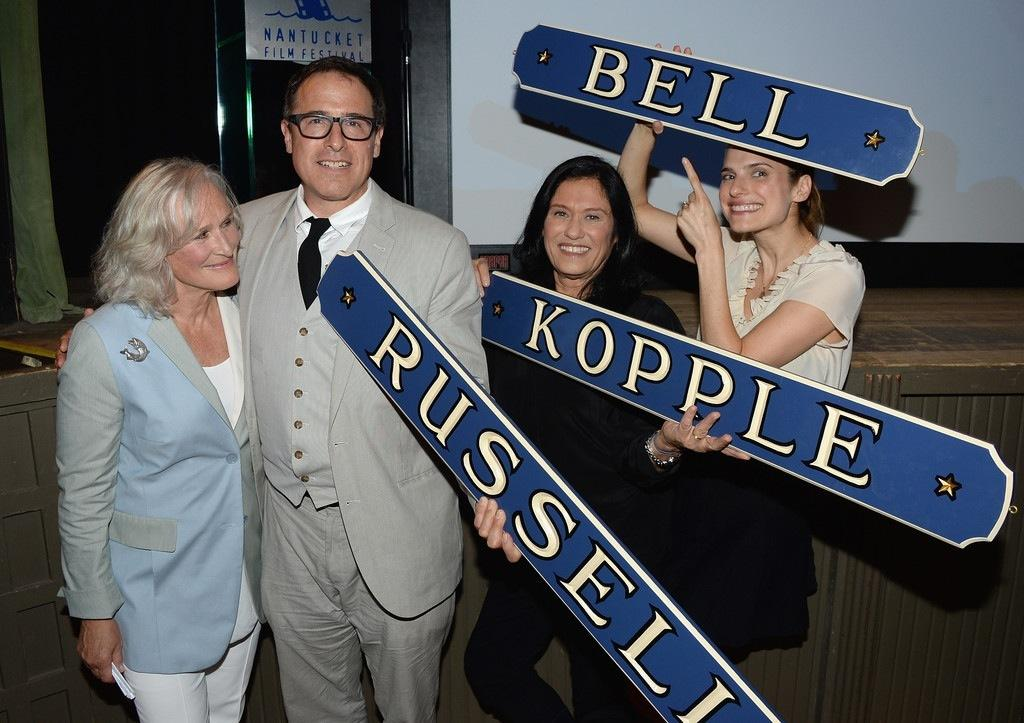What types of people are present in the image? There are men and women standing in the image. What objects can be seen in the image? There are boards in the image. What structure is visible in the image? There is a wall in the image. Where is the stove located in the image? There is no stove present in the image. What type of note can be seen on the wall in the image? There is no note visible on the wall in the image. 